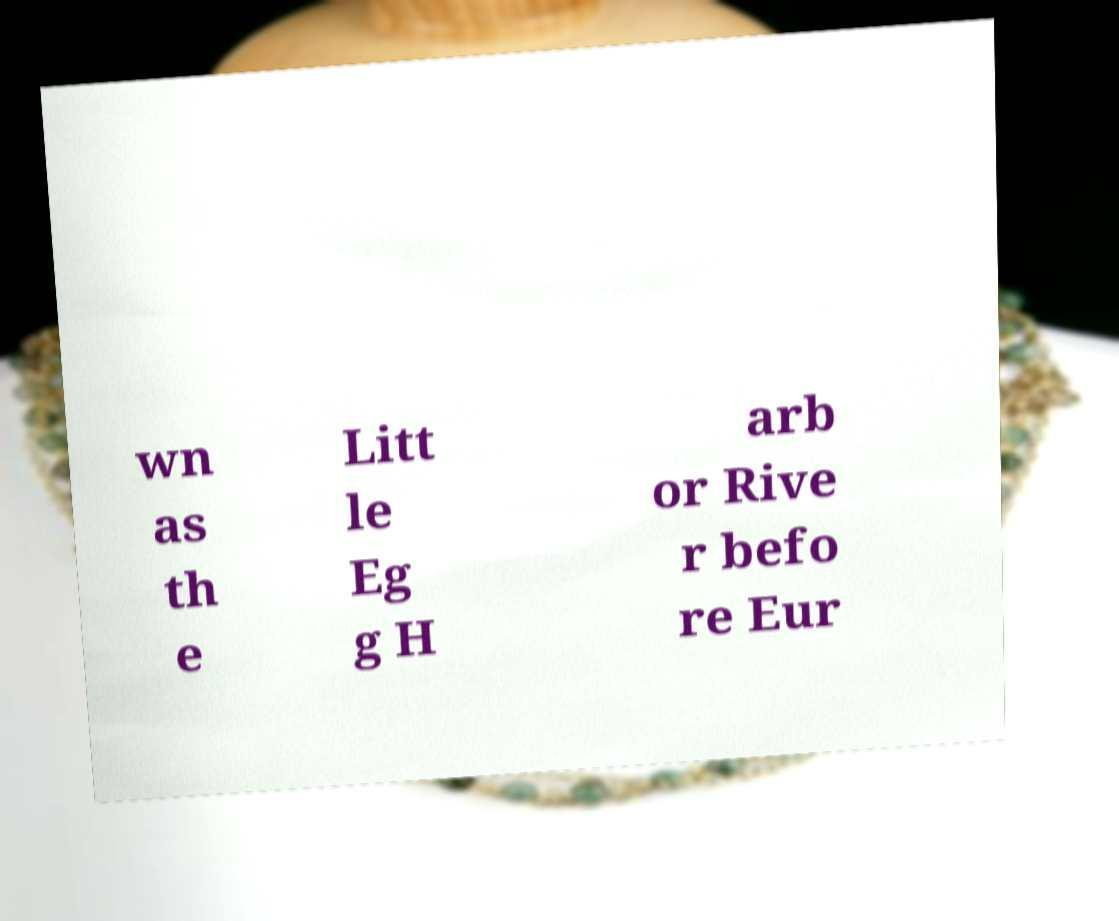Could you extract and type out the text from this image? wn as th e Litt le Eg g H arb or Rive r befo re Eur 